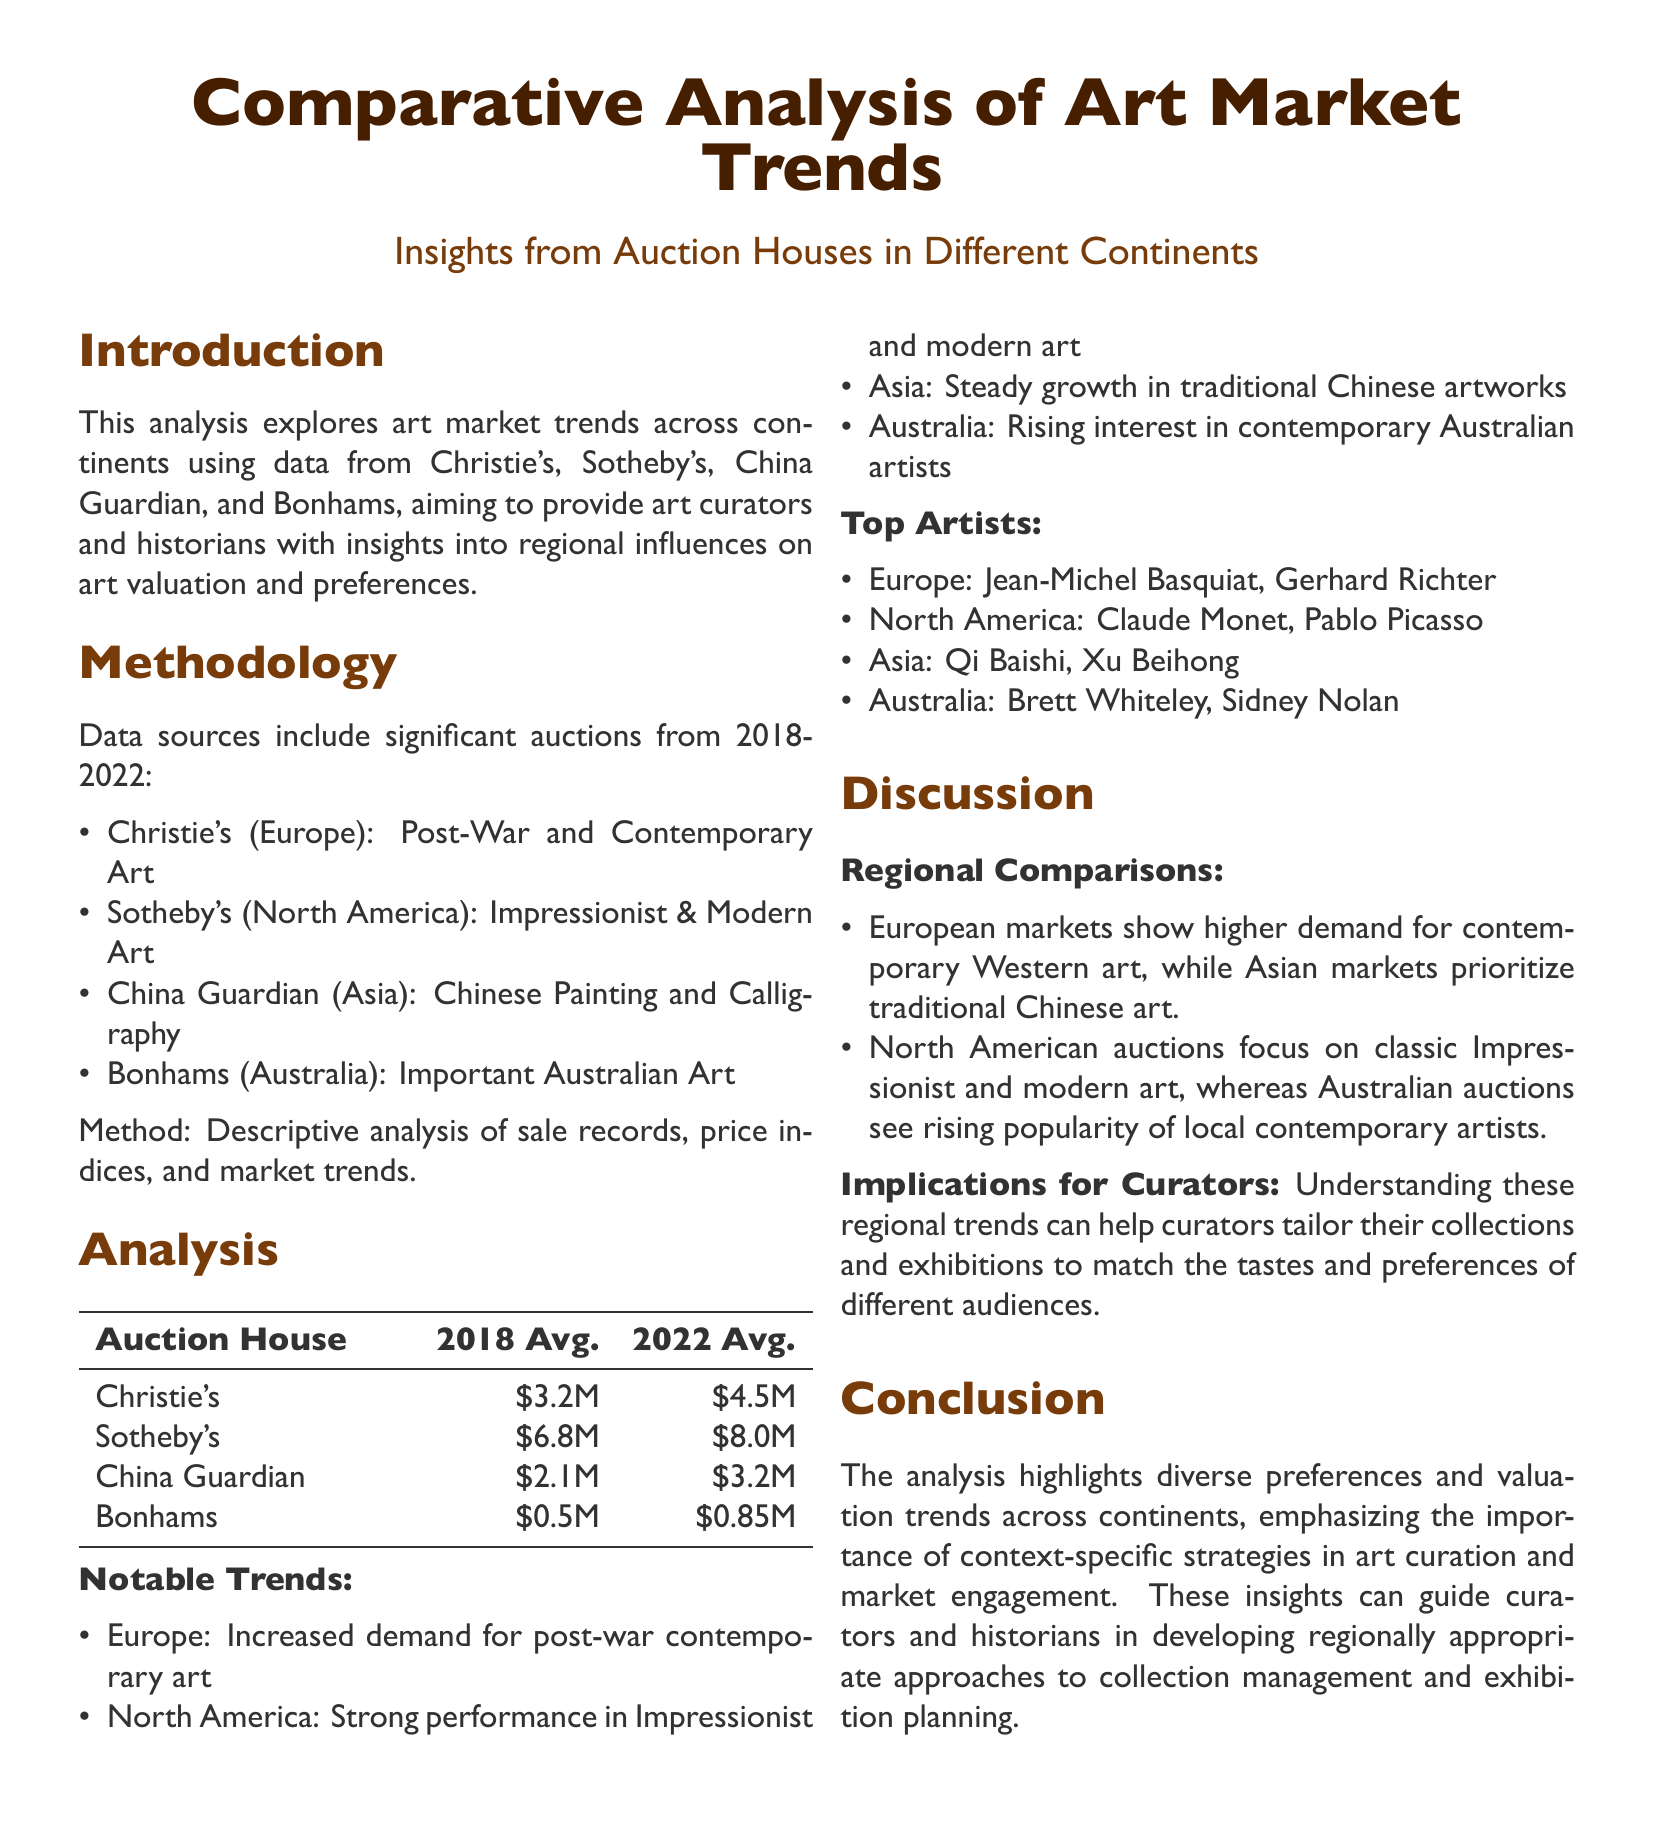What is the average price for Christie's in 2022? The document states that Christie's had an average price of $4.5M in 2022.
Answer: $4.5M Which auction house focuses on Chinese Painting and Calligraphy? The document mentions that China Guardian specializes in Chinese Painting and Calligraphy.
Answer: China Guardian What notable trend is observed in the North American art market? The document highlights that there is a strong performance in Impressionist and modern art in North America.
Answer: Strong performance in Impressionist and modern art Who are the top artists in Asia? The document lists Qi Baishi and Xu Beihong as the top artists in Asia.
Answer: Qi Baishi, Xu Beihong What was the average price for Bonhams in 2018? The document indicates that Bonhams had an average price of $0.5M in 2018.
Answer: $0.5M What is the purpose of this analysis? The document states that the analysis aims to provide insights into regional influences on art valuation and preferences for art curators and historians.
Answer: Provide insights into regional influences Which continent shows a rising interest in contemporary Australian artists? The document notes that Australia is experiencing a rising interest in contemporary Australian artists.
Answer: Australia What method was used for the analysis? The document specifies that a descriptive analysis of sale records, price indices, and market trends was used.
Answer: Descriptive analysis What significant period does the analyzed data cover? The document indicates that the data covers significant auctions from 2018-2022.
Answer: 2018-2022 